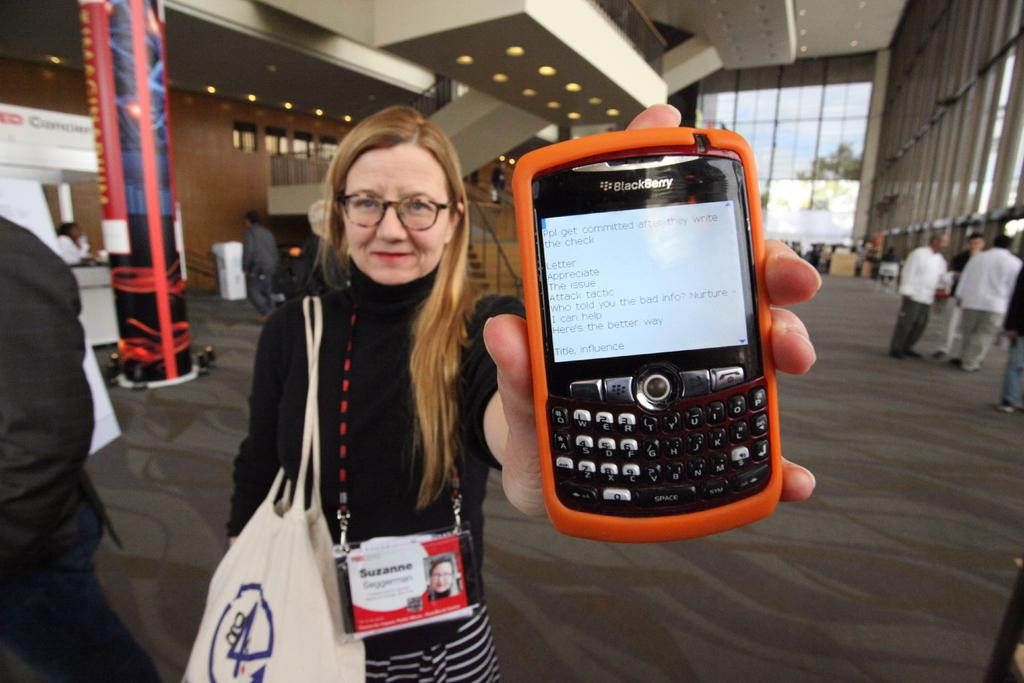<image>
Describe the image concisely. a woman with a Suzanne nametag holding out a Blackberry 